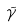<formula> <loc_0><loc_0><loc_500><loc_500>\tilde { \gamma }</formula> 